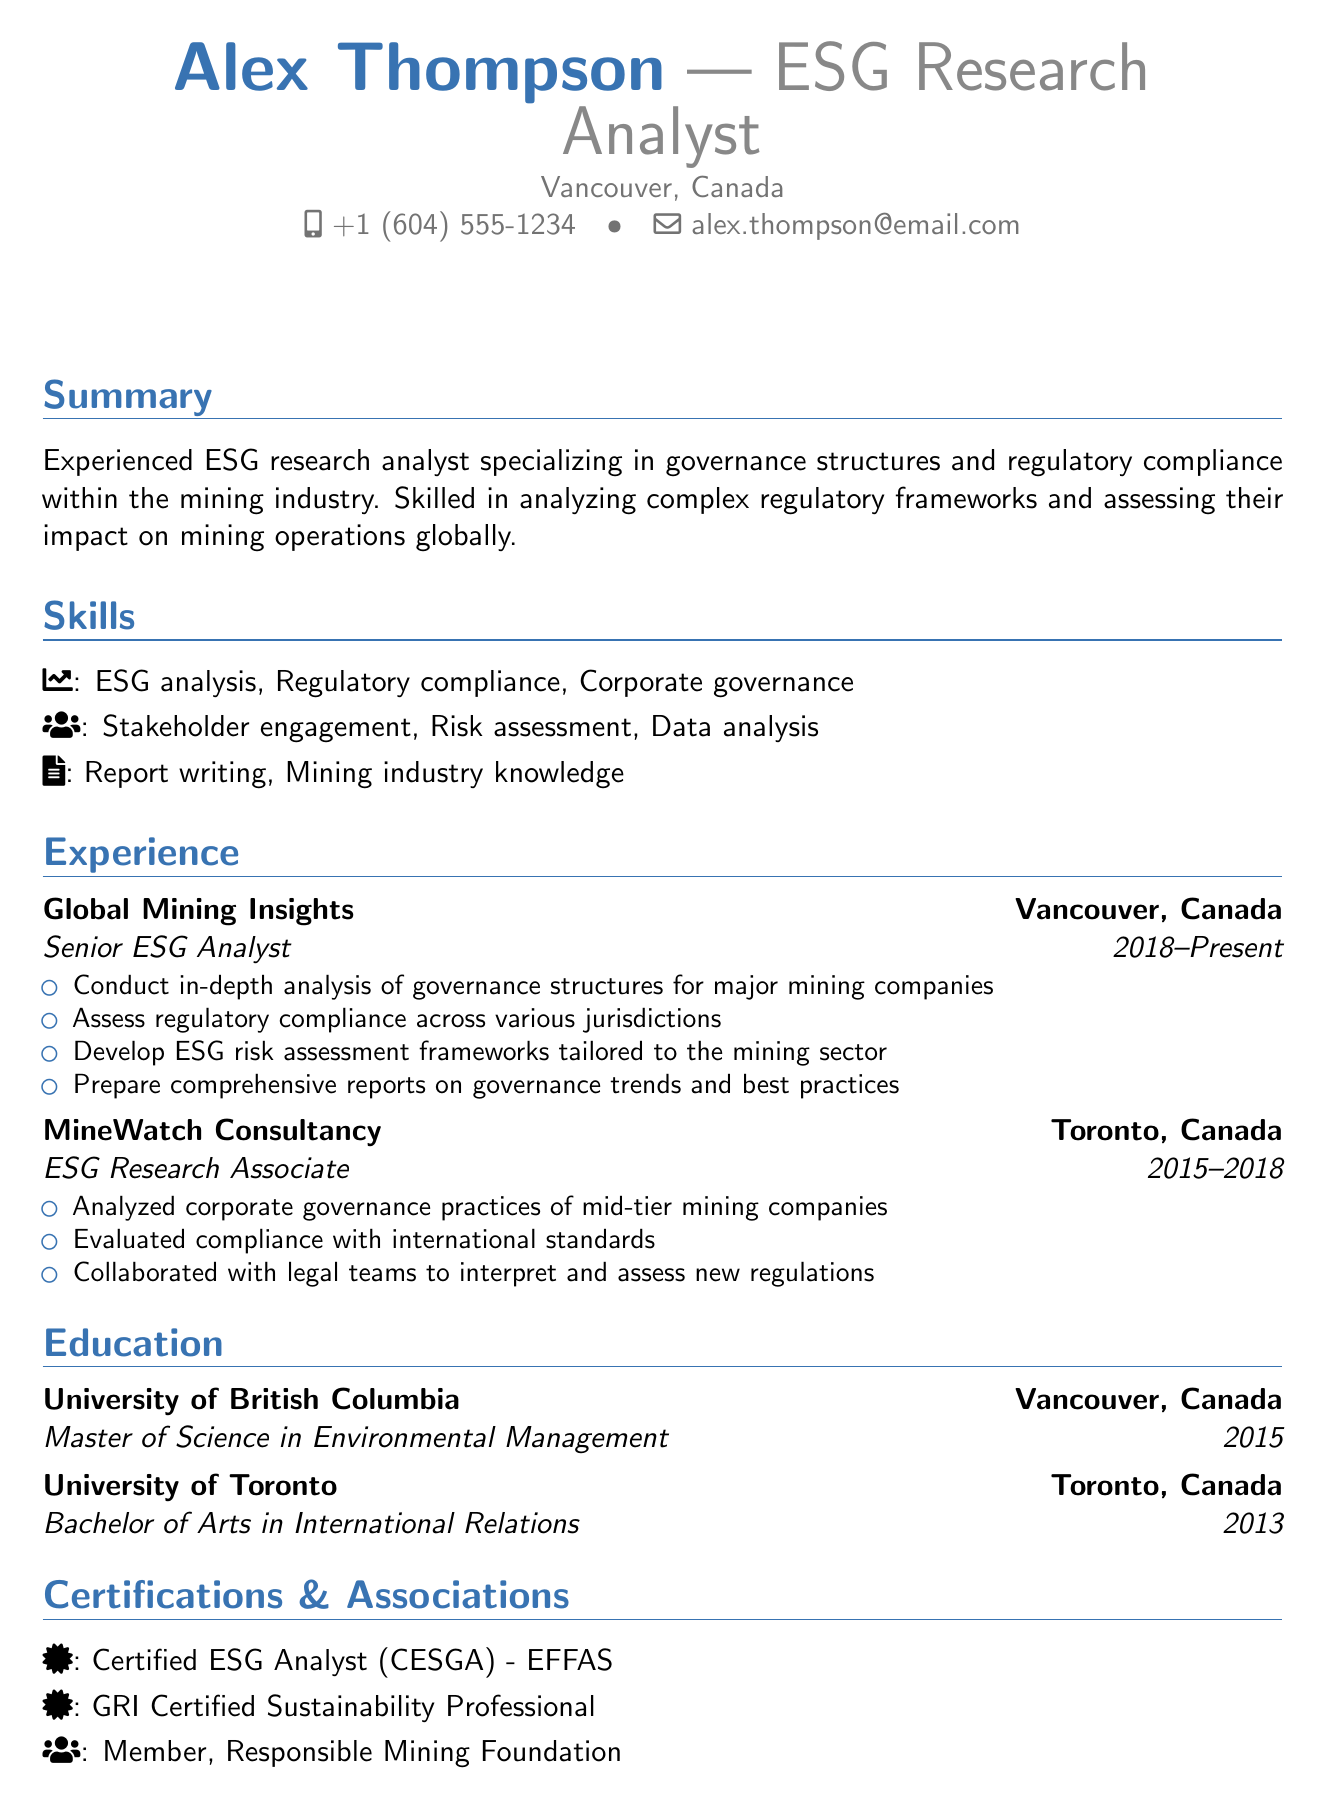What is the name of the researcher? The name of the researcher is stated in the personal information section of the document.
Answer: Alex Thompson What is Alex Thompson’s current job title? The current job title of Alex Thompson is listed in the header of the resume.
Answer: Senior ESG Analyst In which city is Alex Thompson located? The location of Alex Thompson is mentioned in the personal information section.
Answer: Vancouver, Canada What year did Alex Thompson graduate with a Master of Science? The year of graduation for the Master of Science degree is included in the education section.
Answer: 2015 How many years of experience does Alex Thompson have in the ESG field? The experience section shows that Alex Thompson has been working since 2015 and the current date is assumed in 2023, which gives an approximate duration.
Answer: 8 years What organization did Alex work for as an ESG Research Associate? The document specifies the employer for the ESG Research Associate position.
Answer: MineWatch Consultancy Which international framework did Alex evaluate compliance with? The experience section describes the international standards that were evaluated.
Answer: ICMM Principles and the UN Global Compact What type of analysis does Alex Thompson specialize in? The summary section indicates the specific area of analysis Alex specializes in.
Answer: Governance structures and regulatory compliance How many certifications are listed under the certifications section? The certifications section outlines the total number of certifications held by Alex Thompson.
Answer: 2 What professional association is Alex a member of? The document mentions the specific association in the professional associations section.
Answer: Responsible Mining Foundation 